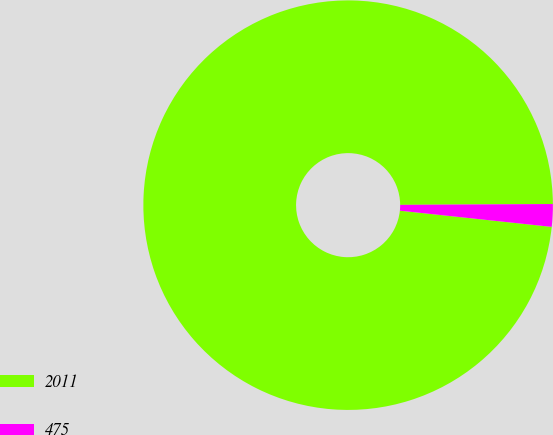<chart> <loc_0><loc_0><loc_500><loc_500><pie_chart><fcel>2011<fcel>475<nl><fcel>98.22%<fcel>1.78%<nl></chart> 